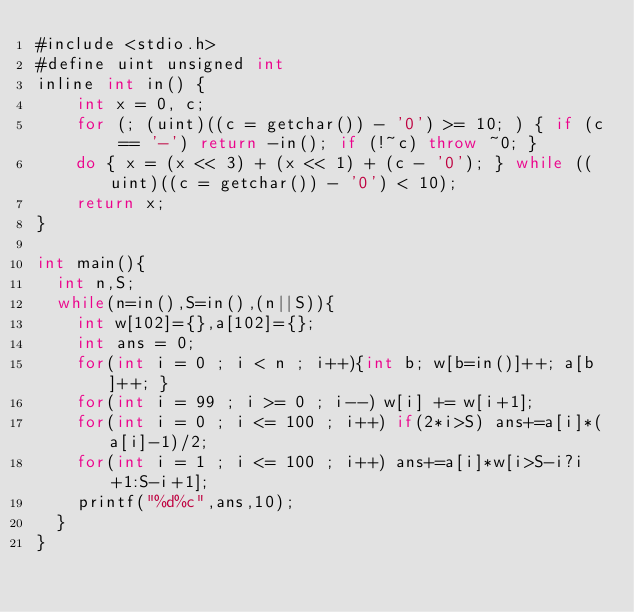Convert code to text. <code><loc_0><loc_0><loc_500><loc_500><_Java_>#include <stdio.h>
#define uint unsigned int
inline int in() {
    int x = 0, c;
    for (; (uint)((c = getchar()) - '0') >= 10; ) { if (c == '-') return -in(); if (!~c) throw ~0; }
    do { x = (x << 3) + (x << 1) + (c - '0'); } while ((uint)((c = getchar()) - '0') < 10);
    return x;
}

int main(){
	int n,S;
	while(n=in(),S=in(),(n||S)){
		int w[102]={},a[102]={};
		int ans = 0;
		for(int i = 0 ; i < n ; i++){int b; w[b=in()]++; a[b]++; }
		for(int i = 99 ; i >= 0 ; i--) w[i] += w[i+1];
		for(int i = 0 ; i <= 100 ; i++) if(2*i>S) ans+=a[i]*(a[i]-1)/2;
		for(int i = 1 ; i <= 100 ; i++) ans+=a[i]*w[i>S-i?i+1:S-i+1];
		printf("%d%c",ans,10);
	}
}</code> 